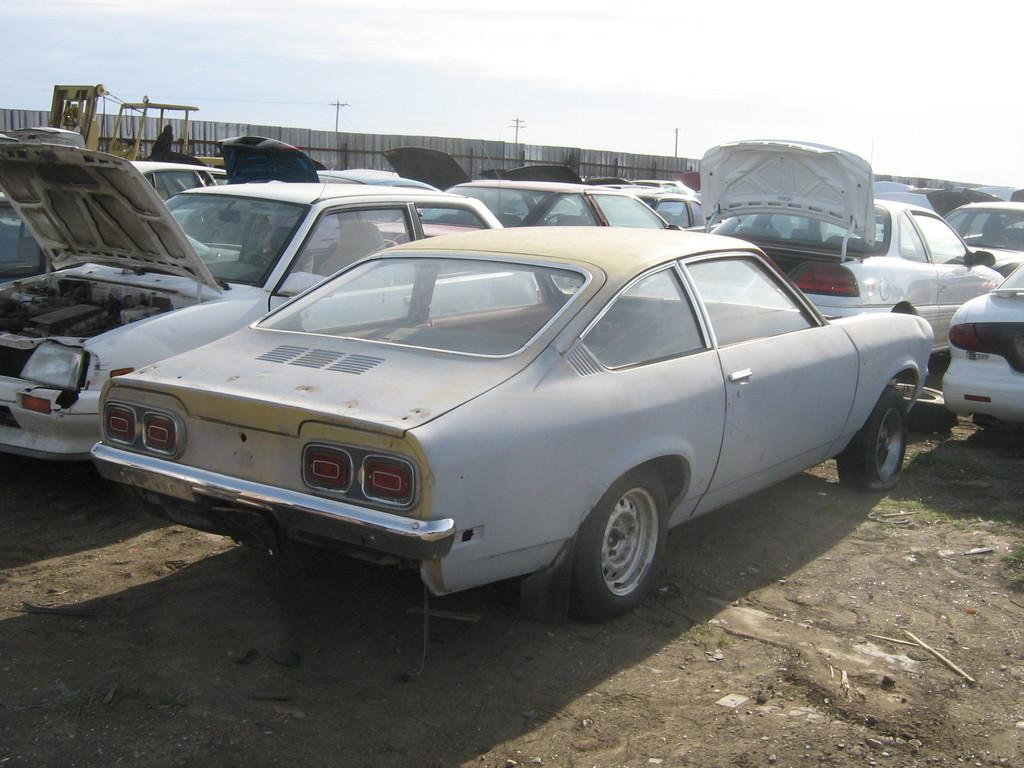What type of vehicles can be seen on the ground in the image? There are cars on the ground in the image. What type of barrier is present in the image? There is a fence in the image. What are the tall, thin structures in the image? There are poles in the image. What type of vegetation is present in the image? There is grass in the image. Can you describe the unspecified objects in the image? Unfortunately, the facts provided do not specify the nature of these objects. What can be seen in the background of the image? The sky is visible in the background of the image. What historical event is being commemorated by the squirrel in the image? There is no squirrel present in the image, and therefore no historical event can be associated with it. 